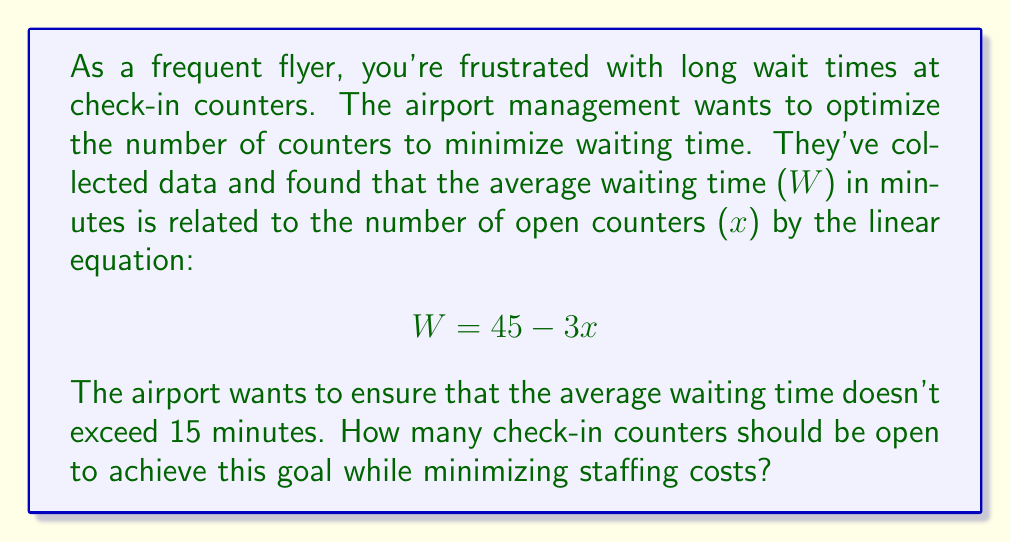Teach me how to tackle this problem. To solve this problem, we need to use the given linear equation and the constraint on waiting time:

1) The linear equation relating waiting time (W) to the number of counters (x) is:
   $$W = 45 - 3x$$

2) We want the waiting time to be no more than 15 minutes:
   $$W \leq 15$$

3) Substituting this into our equation:
   $$45 - 3x \leq 15$$

4) Solving for x:
   $$-3x \leq -30$$
   $$3x \geq 30$$
   $$x \geq 10$$

5) Since x represents the number of counters, it must be a whole number. The smallest whole number that satisfies $x \geq 10$ is 10.

6) To minimize staffing costs, we want the smallest number of counters that meets the waiting time requirement.

Therefore, the optimal number of check-in counters to open is 10.

We can verify:
$$W = 45 - 3(10) = 45 - 30 = 15$$

This gives exactly 15 minutes of waiting time, which meets the requirement.
Answer: The optimal number of check-in counters to open is 10. 